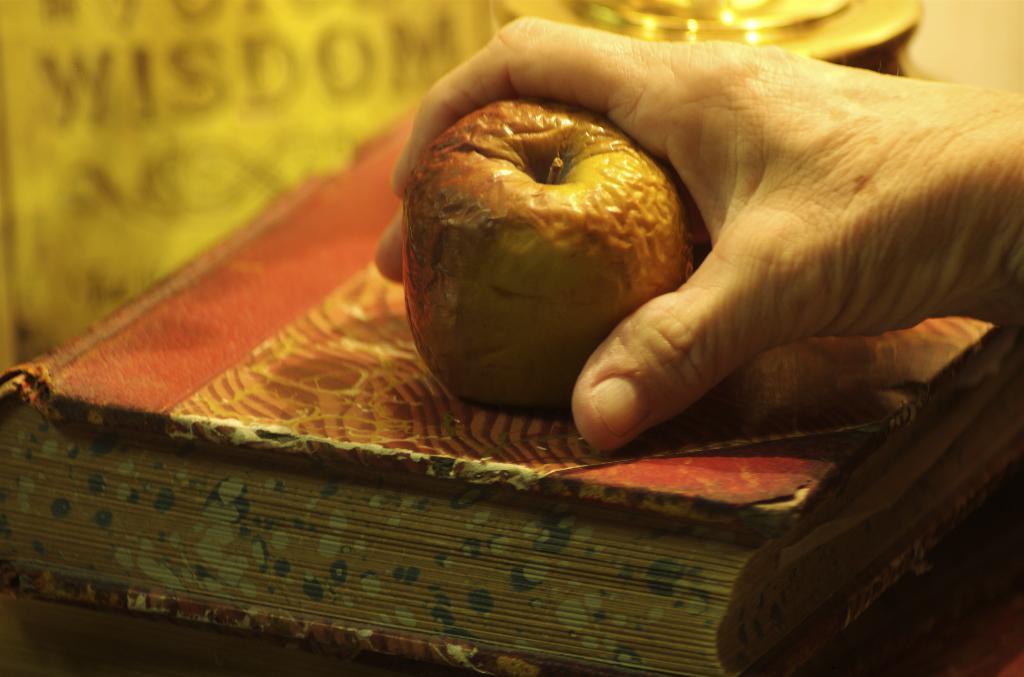Can you describe this image briefly? In this image I can see the person holding the fruit and the fruit is on the book and I can see the brown color background. 